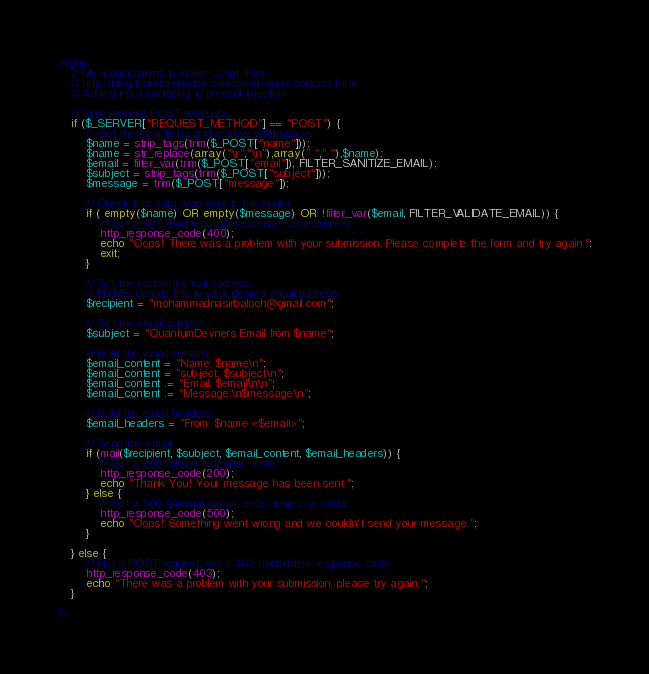<code> <loc_0><loc_0><loc_500><loc_500><_PHP_><?php
    // My modifications to mailer script from:
    // http://blog.teamtreehouse.com/create-ajax-contact-form
    // Added input sanitizing to prevent injection

    // Only process POST reqeusts.
    if ($_SERVER["REQUEST_METHOD"] == "POST") {
        // Get the form fields and remove whitespace.
        $name = strip_tags(trim($_POST["name"]));
		$name = str_replace(array("\r","\n"),array(" "," "),$name);
        $email = filter_var(trim($_POST["email"]), FILTER_SANITIZE_EMAIL);
        $subject = strip_tags(trim($_POST["subject"]));
        $message = trim($_POST["message"]);

        // Check that data was sent to the mailer.
        if ( empty($name) OR empty($message) OR !filter_var($email, FILTER_VALIDATE_EMAIL)) {
            // Set a 400 (bad request) response code and exit.
            http_response_code(400);
            echo "Oops! There was a problem with your submission. Please complete the form and try again.";
            exit;
        }

        // Set the recipient email address.
        // FIXME: Update this to your desired email address.
        $recipient = "mohammadnasirbaloch@gmail.com";

        // Set the email subject.
        $subject = "QuantumDevners Email from $name";

        // Build the email content.
        $email_content = "Name: $name\n";
        $email_content = "subject: $subject\n";
        $email_content .= "Email: $email\n\n";
        $email_content .= "Message:\n$message\n";

        // Build the email headers.
        $email_headers = "From: $name <$email>";

        // Send the email.
        if (mail($recipient, $subject, $email_content, $email_headers)) {
            // Set a 200 (okay) response code.
            http_response_code(200);
            echo "Thank You! Your message has been sent.";
        } else {
            // Set a 500 (internal server error) response code.
            http_response_code(500);
            echo "Oops! Something went wrong and we couldn't send your message.";
        }

    } else {
        // Not a POST request, set a 403 (forbidden) response code.
        http_response_code(403);
        echo "There was a problem with your submission, please try again.";
    }

?>
</code> 